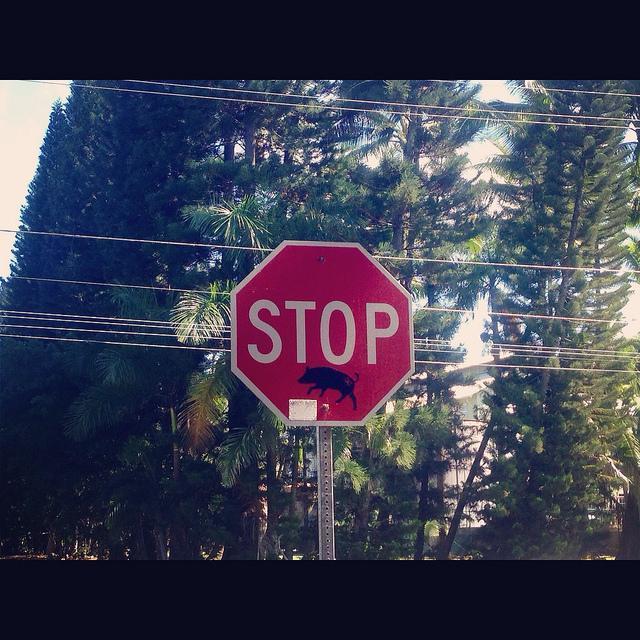How many power lines are there?
Give a very brief answer. 9. 